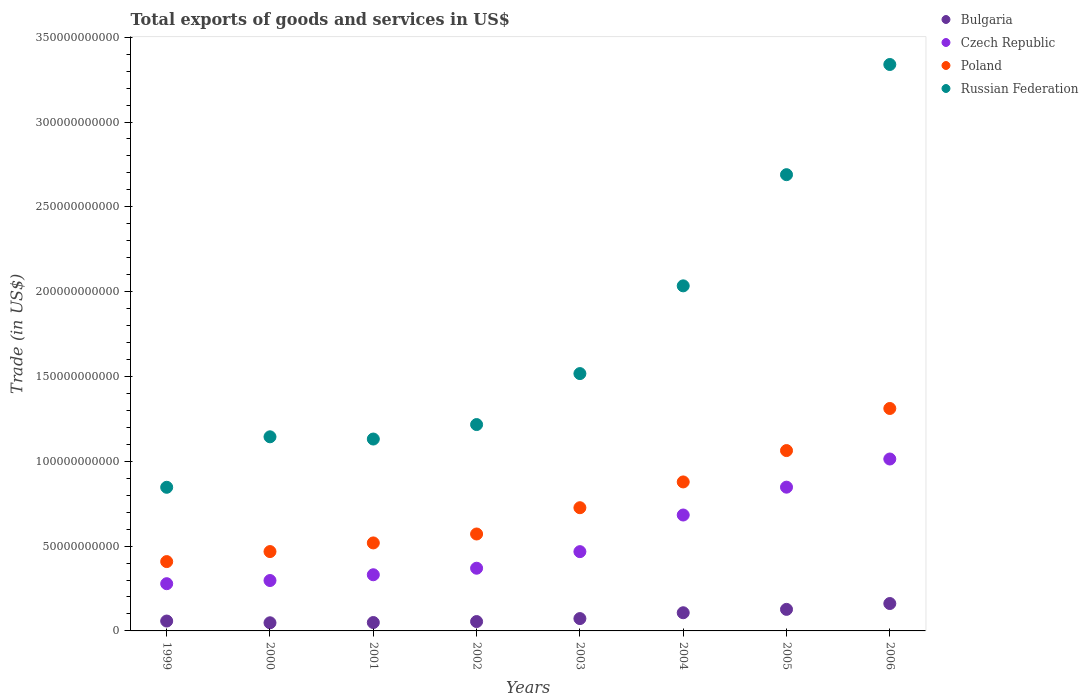What is the total exports of goods and services in Poland in 2003?
Offer a very short reply. 7.26e+1. Across all years, what is the maximum total exports of goods and services in Czech Republic?
Your response must be concise. 1.01e+11. Across all years, what is the minimum total exports of goods and services in Czech Republic?
Your response must be concise. 2.78e+1. In which year was the total exports of goods and services in Czech Republic minimum?
Ensure brevity in your answer.  1999. What is the total total exports of goods and services in Poland in the graph?
Your answer should be compact. 5.95e+11. What is the difference between the total exports of goods and services in Russian Federation in 2001 and that in 2006?
Provide a succinct answer. -2.21e+11. What is the difference between the total exports of goods and services in Czech Republic in 2004 and the total exports of goods and services in Poland in 2002?
Keep it short and to the point. 1.12e+1. What is the average total exports of goods and services in Bulgaria per year?
Offer a very short reply. 8.49e+09. In the year 2001, what is the difference between the total exports of goods and services in Czech Republic and total exports of goods and services in Bulgaria?
Keep it short and to the point. 2.82e+1. What is the ratio of the total exports of goods and services in Russian Federation in 2002 to that in 2003?
Ensure brevity in your answer.  0.8. Is the total exports of goods and services in Bulgaria in 2004 less than that in 2005?
Your answer should be compact. Yes. What is the difference between the highest and the second highest total exports of goods and services in Russian Federation?
Offer a very short reply. 6.50e+1. What is the difference between the highest and the lowest total exports of goods and services in Poland?
Provide a short and direct response. 9.03e+1. In how many years, is the total exports of goods and services in Poland greater than the average total exports of goods and services in Poland taken over all years?
Your answer should be very brief. 3. Is it the case that in every year, the sum of the total exports of goods and services in Poland and total exports of goods and services in Czech Republic  is greater than the sum of total exports of goods and services in Russian Federation and total exports of goods and services in Bulgaria?
Give a very brief answer. Yes. Is it the case that in every year, the sum of the total exports of goods and services in Bulgaria and total exports of goods and services in Poland  is greater than the total exports of goods and services in Czech Republic?
Your answer should be compact. Yes. How many years are there in the graph?
Make the answer very short. 8. What is the difference between two consecutive major ticks on the Y-axis?
Offer a very short reply. 5.00e+1. Does the graph contain grids?
Offer a terse response. No. How many legend labels are there?
Offer a very short reply. 4. What is the title of the graph?
Provide a succinct answer. Total exports of goods and services in US$. Does "Tuvalu" appear as one of the legend labels in the graph?
Offer a terse response. No. What is the label or title of the Y-axis?
Provide a short and direct response. Trade (in US$). What is the Trade (in US$) of Bulgaria in 1999?
Give a very brief answer. 5.83e+09. What is the Trade (in US$) in Czech Republic in 1999?
Provide a succinct answer. 2.78e+1. What is the Trade (in US$) of Poland in 1999?
Offer a very short reply. 4.09e+1. What is the Trade (in US$) in Russian Federation in 1999?
Offer a very short reply. 8.47e+1. What is the Trade (in US$) of Bulgaria in 2000?
Provide a succinct answer. 4.80e+09. What is the Trade (in US$) of Czech Republic in 2000?
Your answer should be compact. 2.97e+1. What is the Trade (in US$) of Poland in 2000?
Offer a very short reply. 4.68e+1. What is the Trade (in US$) in Russian Federation in 2000?
Keep it short and to the point. 1.14e+11. What is the Trade (in US$) in Bulgaria in 2001?
Your answer should be compact. 4.95e+09. What is the Trade (in US$) of Czech Republic in 2001?
Provide a succinct answer. 3.31e+1. What is the Trade (in US$) in Poland in 2001?
Provide a short and direct response. 5.19e+1. What is the Trade (in US$) of Russian Federation in 2001?
Offer a very short reply. 1.13e+11. What is the Trade (in US$) in Bulgaria in 2002?
Your answer should be compact. 5.52e+09. What is the Trade (in US$) in Czech Republic in 2002?
Give a very brief answer. 3.70e+1. What is the Trade (in US$) of Poland in 2002?
Give a very brief answer. 5.71e+1. What is the Trade (in US$) in Russian Federation in 2002?
Keep it short and to the point. 1.22e+11. What is the Trade (in US$) of Bulgaria in 2003?
Ensure brevity in your answer.  7.28e+09. What is the Trade (in US$) in Czech Republic in 2003?
Your answer should be very brief. 4.67e+1. What is the Trade (in US$) of Poland in 2003?
Make the answer very short. 7.26e+1. What is the Trade (in US$) of Russian Federation in 2003?
Give a very brief answer. 1.52e+11. What is the Trade (in US$) in Bulgaria in 2004?
Make the answer very short. 1.07e+1. What is the Trade (in US$) in Czech Republic in 2004?
Your answer should be very brief. 6.83e+1. What is the Trade (in US$) of Poland in 2004?
Keep it short and to the point. 8.78e+1. What is the Trade (in US$) in Russian Federation in 2004?
Your response must be concise. 2.03e+11. What is the Trade (in US$) in Bulgaria in 2005?
Provide a succinct answer. 1.27e+1. What is the Trade (in US$) of Czech Republic in 2005?
Your response must be concise. 8.47e+1. What is the Trade (in US$) of Poland in 2005?
Give a very brief answer. 1.06e+11. What is the Trade (in US$) in Russian Federation in 2005?
Make the answer very short. 2.69e+11. What is the Trade (in US$) of Bulgaria in 2006?
Provide a short and direct response. 1.62e+1. What is the Trade (in US$) in Czech Republic in 2006?
Ensure brevity in your answer.  1.01e+11. What is the Trade (in US$) in Poland in 2006?
Make the answer very short. 1.31e+11. What is the Trade (in US$) of Russian Federation in 2006?
Give a very brief answer. 3.34e+11. Across all years, what is the maximum Trade (in US$) of Bulgaria?
Make the answer very short. 1.62e+1. Across all years, what is the maximum Trade (in US$) of Czech Republic?
Ensure brevity in your answer.  1.01e+11. Across all years, what is the maximum Trade (in US$) in Poland?
Make the answer very short. 1.31e+11. Across all years, what is the maximum Trade (in US$) of Russian Federation?
Your response must be concise. 3.34e+11. Across all years, what is the minimum Trade (in US$) in Bulgaria?
Your answer should be very brief. 4.80e+09. Across all years, what is the minimum Trade (in US$) of Czech Republic?
Offer a terse response. 2.78e+1. Across all years, what is the minimum Trade (in US$) in Poland?
Offer a terse response. 4.09e+1. Across all years, what is the minimum Trade (in US$) in Russian Federation?
Provide a succinct answer. 8.47e+1. What is the total Trade (in US$) in Bulgaria in the graph?
Offer a terse response. 6.79e+1. What is the total Trade (in US$) in Czech Republic in the graph?
Your answer should be compact. 4.29e+11. What is the total Trade (in US$) of Poland in the graph?
Keep it short and to the point. 5.95e+11. What is the total Trade (in US$) in Russian Federation in the graph?
Provide a short and direct response. 1.39e+12. What is the difference between the Trade (in US$) of Bulgaria in 1999 and that in 2000?
Your answer should be very brief. 1.03e+09. What is the difference between the Trade (in US$) of Czech Republic in 1999 and that in 2000?
Your response must be concise. -1.87e+09. What is the difference between the Trade (in US$) in Poland in 1999 and that in 2000?
Offer a terse response. -5.90e+09. What is the difference between the Trade (in US$) in Russian Federation in 1999 and that in 2000?
Your answer should be very brief. -2.98e+1. What is the difference between the Trade (in US$) in Bulgaria in 1999 and that in 2001?
Your answer should be very brief. 8.78e+08. What is the difference between the Trade (in US$) in Czech Republic in 1999 and that in 2001?
Keep it short and to the point. -5.26e+09. What is the difference between the Trade (in US$) in Poland in 1999 and that in 2001?
Offer a very short reply. -1.10e+1. What is the difference between the Trade (in US$) of Russian Federation in 1999 and that in 2001?
Offer a terse response. -2.84e+1. What is the difference between the Trade (in US$) of Bulgaria in 1999 and that in 2002?
Provide a short and direct response. 3.07e+08. What is the difference between the Trade (in US$) in Czech Republic in 1999 and that in 2002?
Keep it short and to the point. -9.12e+09. What is the difference between the Trade (in US$) of Poland in 1999 and that in 2002?
Ensure brevity in your answer.  -1.63e+1. What is the difference between the Trade (in US$) in Russian Federation in 1999 and that in 2002?
Provide a short and direct response. -3.70e+1. What is the difference between the Trade (in US$) of Bulgaria in 1999 and that in 2003?
Offer a terse response. -1.45e+09. What is the difference between the Trade (in US$) in Czech Republic in 1999 and that in 2003?
Offer a terse response. -1.89e+1. What is the difference between the Trade (in US$) of Poland in 1999 and that in 2003?
Provide a succinct answer. -3.18e+1. What is the difference between the Trade (in US$) in Russian Federation in 1999 and that in 2003?
Provide a succinct answer. -6.70e+1. What is the difference between the Trade (in US$) of Bulgaria in 1999 and that in 2004?
Provide a short and direct response. -4.89e+09. What is the difference between the Trade (in US$) of Czech Republic in 1999 and that in 2004?
Provide a succinct answer. -4.05e+1. What is the difference between the Trade (in US$) of Poland in 1999 and that in 2004?
Make the answer very short. -4.70e+1. What is the difference between the Trade (in US$) of Russian Federation in 1999 and that in 2004?
Your answer should be very brief. -1.19e+11. What is the difference between the Trade (in US$) in Bulgaria in 1999 and that in 2005?
Offer a terse response. -6.88e+09. What is the difference between the Trade (in US$) of Czech Republic in 1999 and that in 2005?
Give a very brief answer. -5.69e+1. What is the difference between the Trade (in US$) of Poland in 1999 and that in 2005?
Your response must be concise. -6.54e+1. What is the difference between the Trade (in US$) of Russian Federation in 1999 and that in 2005?
Offer a very short reply. -1.84e+11. What is the difference between the Trade (in US$) in Bulgaria in 1999 and that in 2006?
Give a very brief answer. -1.03e+1. What is the difference between the Trade (in US$) of Czech Republic in 1999 and that in 2006?
Give a very brief answer. -7.35e+1. What is the difference between the Trade (in US$) of Poland in 1999 and that in 2006?
Provide a short and direct response. -9.03e+1. What is the difference between the Trade (in US$) of Russian Federation in 1999 and that in 2006?
Provide a short and direct response. -2.49e+11. What is the difference between the Trade (in US$) in Bulgaria in 2000 and that in 2001?
Provide a short and direct response. -1.50e+08. What is the difference between the Trade (in US$) of Czech Republic in 2000 and that in 2001?
Keep it short and to the point. -3.40e+09. What is the difference between the Trade (in US$) in Poland in 2000 and that in 2001?
Your answer should be very brief. -5.10e+09. What is the difference between the Trade (in US$) of Russian Federation in 2000 and that in 2001?
Ensure brevity in your answer.  1.31e+09. What is the difference between the Trade (in US$) of Bulgaria in 2000 and that in 2002?
Offer a very short reply. -7.22e+08. What is the difference between the Trade (in US$) in Czech Republic in 2000 and that in 2002?
Make the answer very short. -7.25e+09. What is the difference between the Trade (in US$) of Poland in 2000 and that in 2002?
Offer a terse response. -1.04e+1. What is the difference between the Trade (in US$) of Russian Federation in 2000 and that in 2002?
Your answer should be compact. -7.22e+09. What is the difference between the Trade (in US$) of Bulgaria in 2000 and that in 2003?
Make the answer very short. -2.48e+09. What is the difference between the Trade (in US$) of Czech Republic in 2000 and that in 2003?
Offer a terse response. -1.70e+1. What is the difference between the Trade (in US$) of Poland in 2000 and that in 2003?
Keep it short and to the point. -2.59e+1. What is the difference between the Trade (in US$) in Russian Federation in 2000 and that in 2003?
Ensure brevity in your answer.  -3.73e+1. What is the difference between the Trade (in US$) in Bulgaria in 2000 and that in 2004?
Provide a short and direct response. -5.92e+09. What is the difference between the Trade (in US$) in Czech Republic in 2000 and that in 2004?
Keep it short and to the point. -3.86e+1. What is the difference between the Trade (in US$) in Poland in 2000 and that in 2004?
Make the answer very short. -4.11e+1. What is the difference between the Trade (in US$) in Russian Federation in 2000 and that in 2004?
Provide a succinct answer. -8.90e+1. What is the difference between the Trade (in US$) in Bulgaria in 2000 and that in 2005?
Your answer should be compact. -7.91e+09. What is the difference between the Trade (in US$) of Czech Republic in 2000 and that in 2005?
Keep it short and to the point. -5.50e+1. What is the difference between the Trade (in US$) in Poland in 2000 and that in 2005?
Offer a very short reply. -5.95e+1. What is the difference between the Trade (in US$) of Russian Federation in 2000 and that in 2005?
Offer a terse response. -1.55e+11. What is the difference between the Trade (in US$) of Bulgaria in 2000 and that in 2006?
Offer a very short reply. -1.14e+1. What is the difference between the Trade (in US$) of Czech Republic in 2000 and that in 2006?
Make the answer very short. -7.16e+1. What is the difference between the Trade (in US$) of Poland in 2000 and that in 2006?
Keep it short and to the point. -8.44e+1. What is the difference between the Trade (in US$) of Russian Federation in 2000 and that in 2006?
Your answer should be compact. -2.19e+11. What is the difference between the Trade (in US$) of Bulgaria in 2001 and that in 2002?
Ensure brevity in your answer.  -5.72e+08. What is the difference between the Trade (in US$) of Czech Republic in 2001 and that in 2002?
Give a very brief answer. -3.86e+09. What is the difference between the Trade (in US$) of Poland in 2001 and that in 2002?
Keep it short and to the point. -5.26e+09. What is the difference between the Trade (in US$) in Russian Federation in 2001 and that in 2002?
Your response must be concise. -8.53e+09. What is the difference between the Trade (in US$) of Bulgaria in 2001 and that in 2003?
Offer a terse response. -2.33e+09. What is the difference between the Trade (in US$) in Czech Republic in 2001 and that in 2003?
Your answer should be compact. -1.36e+1. What is the difference between the Trade (in US$) of Poland in 2001 and that in 2003?
Offer a very short reply. -2.08e+1. What is the difference between the Trade (in US$) in Russian Federation in 2001 and that in 2003?
Provide a succinct answer. -3.86e+1. What is the difference between the Trade (in US$) of Bulgaria in 2001 and that in 2004?
Give a very brief answer. -5.77e+09. What is the difference between the Trade (in US$) in Czech Republic in 2001 and that in 2004?
Your response must be concise. -3.52e+1. What is the difference between the Trade (in US$) of Poland in 2001 and that in 2004?
Make the answer very short. -3.60e+1. What is the difference between the Trade (in US$) in Russian Federation in 2001 and that in 2004?
Your answer should be very brief. -9.03e+1. What is the difference between the Trade (in US$) in Bulgaria in 2001 and that in 2005?
Give a very brief answer. -7.76e+09. What is the difference between the Trade (in US$) of Czech Republic in 2001 and that in 2005?
Offer a very short reply. -5.16e+1. What is the difference between the Trade (in US$) of Poland in 2001 and that in 2005?
Provide a succinct answer. -5.44e+1. What is the difference between the Trade (in US$) in Russian Federation in 2001 and that in 2005?
Provide a short and direct response. -1.56e+11. What is the difference between the Trade (in US$) in Bulgaria in 2001 and that in 2006?
Your answer should be compact. -1.12e+1. What is the difference between the Trade (in US$) in Czech Republic in 2001 and that in 2006?
Give a very brief answer. -6.82e+1. What is the difference between the Trade (in US$) of Poland in 2001 and that in 2006?
Your answer should be compact. -7.93e+1. What is the difference between the Trade (in US$) in Russian Federation in 2001 and that in 2006?
Make the answer very short. -2.21e+11. What is the difference between the Trade (in US$) of Bulgaria in 2002 and that in 2003?
Make the answer very short. -1.76e+09. What is the difference between the Trade (in US$) of Czech Republic in 2002 and that in 2003?
Your response must be concise. -9.77e+09. What is the difference between the Trade (in US$) of Poland in 2002 and that in 2003?
Offer a very short reply. -1.55e+1. What is the difference between the Trade (in US$) in Russian Federation in 2002 and that in 2003?
Provide a succinct answer. -3.00e+1. What is the difference between the Trade (in US$) of Bulgaria in 2002 and that in 2004?
Offer a terse response. -5.19e+09. What is the difference between the Trade (in US$) of Czech Republic in 2002 and that in 2004?
Your response must be concise. -3.14e+1. What is the difference between the Trade (in US$) of Poland in 2002 and that in 2004?
Your answer should be very brief. -3.07e+1. What is the difference between the Trade (in US$) in Russian Federation in 2002 and that in 2004?
Keep it short and to the point. -8.18e+1. What is the difference between the Trade (in US$) in Bulgaria in 2002 and that in 2005?
Keep it short and to the point. -7.18e+09. What is the difference between the Trade (in US$) of Czech Republic in 2002 and that in 2005?
Offer a very short reply. -4.78e+1. What is the difference between the Trade (in US$) of Poland in 2002 and that in 2005?
Give a very brief answer. -4.92e+1. What is the difference between the Trade (in US$) in Russian Federation in 2002 and that in 2005?
Make the answer very short. -1.47e+11. What is the difference between the Trade (in US$) of Bulgaria in 2002 and that in 2006?
Give a very brief answer. -1.06e+1. What is the difference between the Trade (in US$) of Czech Republic in 2002 and that in 2006?
Give a very brief answer. -6.44e+1. What is the difference between the Trade (in US$) of Poland in 2002 and that in 2006?
Keep it short and to the point. -7.40e+1. What is the difference between the Trade (in US$) of Russian Federation in 2002 and that in 2006?
Give a very brief answer. -2.12e+11. What is the difference between the Trade (in US$) in Bulgaria in 2003 and that in 2004?
Offer a terse response. -3.44e+09. What is the difference between the Trade (in US$) of Czech Republic in 2003 and that in 2004?
Keep it short and to the point. -2.16e+1. What is the difference between the Trade (in US$) in Poland in 2003 and that in 2004?
Keep it short and to the point. -1.52e+1. What is the difference between the Trade (in US$) of Russian Federation in 2003 and that in 2004?
Offer a terse response. -5.17e+1. What is the difference between the Trade (in US$) in Bulgaria in 2003 and that in 2005?
Ensure brevity in your answer.  -5.43e+09. What is the difference between the Trade (in US$) in Czech Republic in 2003 and that in 2005?
Offer a terse response. -3.80e+1. What is the difference between the Trade (in US$) in Poland in 2003 and that in 2005?
Your answer should be compact. -3.37e+1. What is the difference between the Trade (in US$) of Russian Federation in 2003 and that in 2005?
Your answer should be very brief. -1.17e+11. What is the difference between the Trade (in US$) in Bulgaria in 2003 and that in 2006?
Your answer should be very brief. -8.87e+09. What is the difference between the Trade (in US$) of Czech Republic in 2003 and that in 2006?
Your answer should be very brief. -5.46e+1. What is the difference between the Trade (in US$) in Poland in 2003 and that in 2006?
Provide a short and direct response. -5.85e+1. What is the difference between the Trade (in US$) of Russian Federation in 2003 and that in 2006?
Your answer should be compact. -1.82e+11. What is the difference between the Trade (in US$) in Bulgaria in 2004 and that in 2005?
Make the answer very short. -1.99e+09. What is the difference between the Trade (in US$) of Czech Republic in 2004 and that in 2005?
Your response must be concise. -1.64e+1. What is the difference between the Trade (in US$) of Poland in 2004 and that in 2005?
Offer a very short reply. -1.85e+1. What is the difference between the Trade (in US$) of Russian Federation in 2004 and that in 2005?
Provide a short and direct response. -6.55e+1. What is the difference between the Trade (in US$) in Bulgaria in 2004 and that in 2006?
Offer a very short reply. -5.44e+09. What is the difference between the Trade (in US$) in Czech Republic in 2004 and that in 2006?
Offer a terse response. -3.30e+1. What is the difference between the Trade (in US$) of Poland in 2004 and that in 2006?
Your response must be concise. -4.33e+1. What is the difference between the Trade (in US$) in Russian Federation in 2004 and that in 2006?
Your response must be concise. -1.30e+11. What is the difference between the Trade (in US$) of Bulgaria in 2005 and that in 2006?
Offer a very short reply. -3.45e+09. What is the difference between the Trade (in US$) in Czech Republic in 2005 and that in 2006?
Give a very brief answer. -1.66e+1. What is the difference between the Trade (in US$) of Poland in 2005 and that in 2006?
Give a very brief answer. -2.48e+1. What is the difference between the Trade (in US$) of Russian Federation in 2005 and that in 2006?
Your response must be concise. -6.50e+1. What is the difference between the Trade (in US$) of Bulgaria in 1999 and the Trade (in US$) of Czech Republic in 2000?
Your answer should be very brief. -2.39e+1. What is the difference between the Trade (in US$) of Bulgaria in 1999 and the Trade (in US$) of Poland in 2000?
Your response must be concise. -4.09e+1. What is the difference between the Trade (in US$) in Bulgaria in 1999 and the Trade (in US$) in Russian Federation in 2000?
Ensure brevity in your answer.  -1.09e+11. What is the difference between the Trade (in US$) of Czech Republic in 1999 and the Trade (in US$) of Poland in 2000?
Provide a succinct answer. -1.89e+1. What is the difference between the Trade (in US$) in Czech Republic in 1999 and the Trade (in US$) in Russian Federation in 2000?
Provide a short and direct response. -8.66e+1. What is the difference between the Trade (in US$) in Poland in 1999 and the Trade (in US$) in Russian Federation in 2000?
Keep it short and to the point. -7.36e+1. What is the difference between the Trade (in US$) of Bulgaria in 1999 and the Trade (in US$) of Czech Republic in 2001?
Provide a short and direct response. -2.73e+1. What is the difference between the Trade (in US$) in Bulgaria in 1999 and the Trade (in US$) in Poland in 2001?
Provide a succinct answer. -4.60e+1. What is the difference between the Trade (in US$) in Bulgaria in 1999 and the Trade (in US$) in Russian Federation in 2001?
Make the answer very short. -1.07e+11. What is the difference between the Trade (in US$) in Czech Republic in 1999 and the Trade (in US$) in Poland in 2001?
Give a very brief answer. -2.40e+1. What is the difference between the Trade (in US$) in Czech Republic in 1999 and the Trade (in US$) in Russian Federation in 2001?
Your answer should be compact. -8.53e+1. What is the difference between the Trade (in US$) in Poland in 1999 and the Trade (in US$) in Russian Federation in 2001?
Give a very brief answer. -7.22e+1. What is the difference between the Trade (in US$) of Bulgaria in 1999 and the Trade (in US$) of Czech Republic in 2002?
Provide a succinct answer. -3.11e+1. What is the difference between the Trade (in US$) of Bulgaria in 1999 and the Trade (in US$) of Poland in 2002?
Provide a succinct answer. -5.13e+1. What is the difference between the Trade (in US$) in Bulgaria in 1999 and the Trade (in US$) in Russian Federation in 2002?
Provide a short and direct response. -1.16e+11. What is the difference between the Trade (in US$) in Czech Republic in 1999 and the Trade (in US$) in Poland in 2002?
Make the answer very short. -2.93e+1. What is the difference between the Trade (in US$) in Czech Republic in 1999 and the Trade (in US$) in Russian Federation in 2002?
Provide a short and direct response. -9.38e+1. What is the difference between the Trade (in US$) in Poland in 1999 and the Trade (in US$) in Russian Federation in 2002?
Your answer should be very brief. -8.08e+1. What is the difference between the Trade (in US$) in Bulgaria in 1999 and the Trade (in US$) in Czech Republic in 2003?
Your response must be concise. -4.09e+1. What is the difference between the Trade (in US$) in Bulgaria in 1999 and the Trade (in US$) in Poland in 2003?
Ensure brevity in your answer.  -6.68e+1. What is the difference between the Trade (in US$) of Bulgaria in 1999 and the Trade (in US$) of Russian Federation in 2003?
Give a very brief answer. -1.46e+11. What is the difference between the Trade (in US$) in Czech Republic in 1999 and the Trade (in US$) in Poland in 2003?
Ensure brevity in your answer.  -4.48e+1. What is the difference between the Trade (in US$) of Czech Republic in 1999 and the Trade (in US$) of Russian Federation in 2003?
Make the answer very short. -1.24e+11. What is the difference between the Trade (in US$) in Poland in 1999 and the Trade (in US$) in Russian Federation in 2003?
Your answer should be compact. -1.11e+11. What is the difference between the Trade (in US$) of Bulgaria in 1999 and the Trade (in US$) of Czech Republic in 2004?
Keep it short and to the point. -6.25e+1. What is the difference between the Trade (in US$) of Bulgaria in 1999 and the Trade (in US$) of Poland in 2004?
Your response must be concise. -8.20e+1. What is the difference between the Trade (in US$) of Bulgaria in 1999 and the Trade (in US$) of Russian Federation in 2004?
Offer a very short reply. -1.98e+11. What is the difference between the Trade (in US$) of Czech Republic in 1999 and the Trade (in US$) of Poland in 2004?
Your answer should be very brief. -6.00e+1. What is the difference between the Trade (in US$) of Czech Republic in 1999 and the Trade (in US$) of Russian Federation in 2004?
Keep it short and to the point. -1.76e+11. What is the difference between the Trade (in US$) of Poland in 1999 and the Trade (in US$) of Russian Federation in 2004?
Give a very brief answer. -1.63e+11. What is the difference between the Trade (in US$) in Bulgaria in 1999 and the Trade (in US$) in Czech Republic in 2005?
Offer a very short reply. -7.89e+1. What is the difference between the Trade (in US$) in Bulgaria in 1999 and the Trade (in US$) in Poland in 2005?
Your answer should be compact. -1.00e+11. What is the difference between the Trade (in US$) of Bulgaria in 1999 and the Trade (in US$) of Russian Federation in 2005?
Provide a succinct answer. -2.63e+11. What is the difference between the Trade (in US$) in Czech Republic in 1999 and the Trade (in US$) in Poland in 2005?
Provide a short and direct response. -7.85e+1. What is the difference between the Trade (in US$) in Czech Republic in 1999 and the Trade (in US$) in Russian Federation in 2005?
Ensure brevity in your answer.  -2.41e+11. What is the difference between the Trade (in US$) in Poland in 1999 and the Trade (in US$) in Russian Federation in 2005?
Your response must be concise. -2.28e+11. What is the difference between the Trade (in US$) of Bulgaria in 1999 and the Trade (in US$) of Czech Republic in 2006?
Provide a succinct answer. -9.55e+1. What is the difference between the Trade (in US$) in Bulgaria in 1999 and the Trade (in US$) in Poland in 2006?
Provide a short and direct response. -1.25e+11. What is the difference between the Trade (in US$) of Bulgaria in 1999 and the Trade (in US$) of Russian Federation in 2006?
Provide a short and direct response. -3.28e+11. What is the difference between the Trade (in US$) in Czech Republic in 1999 and the Trade (in US$) in Poland in 2006?
Make the answer very short. -1.03e+11. What is the difference between the Trade (in US$) in Czech Republic in 1999 and the Trade (in US$) in Russian Federation in 2006?
Make the answer very short. -3.06e+11. What is the difference between the Trade (in US$) in Poland in 1999 and the Trade (in US$) in Russian Federation in 2006?
Provide a succinct answer. -2.93e+11. What is the difference between the Trade (in US$) in Bulgaria in 2000 and the Trade (in US$) in Czech Republic in 2001?
Offer a terse response. -2.83e+1. What is the difference between the Trade (in US$) of Bulgaria in 2000 and the Trade (in US$) of Poland in 2001?
Make the answer very short. -4.71e+1. What is the difference between the Trade (in US$) of Bulgaria in 2000 and the Trade (in US$) of Russian Federation in 2001?
Give a very brief answer. -1.08e+11. What is the difference between the Trade (in US$) in Czech Republic in 2000 and the Trade (in US$) in Poland in 2001?
Keep it short and to the point. -2.22e+1. What is the difference between the Trade (in US$) of Czech Republic in 2000 and the Trade (in US$) of Russian Federation in 2001?
Your response must be concise. -8.34e+1. What is the difference between the Trade (in US$) in Poland in 2000 and the Trade (in US$) in Russian Federation in 2001?
Offer a terse response. -6.63e+1. What is the difference between the Trade (in US$) of Bulgaria in 2000 and the Trade (in US$) of Czech Republic in 2002?
Your answer should be very brief. -3.22e+1. What is the difference between the Trade (in US$) of Bulgaria in 2000 and the Trade (in US$) of Poland in 2002?
Offer a terse response. -5.23e+1. What is the difference between the Trade (in US$) of Bulgaria in 2000 and the Trade (in US$) of Russian Federation in 2002?
Offer a terse response. -1.17e+11. What is the difference between the Trade (in US$) of Czech Republic in 2000 and the Trade (in US$) of Poland in 2002?
Your response must be concise. -2.74e+1. What is the difference between the Trade (in US$) in Czech Republic in 2000 and the Trade (in US$) in Russian Federation in 2002?
Your response must be concise. -9.19e+1. What is the difference between the Trade (in US$) of Poland in 2000 and the Trade (in US$) of Russian Federation in 2002?
Your answer should be compact. -7.49e+1. What is the difference between the Trade (in US$) of Bulgaria in 2000 and the Trade (in US$) of Czech Republic in 2003?
Your answer should be compact. -4.19e+1. What is the difference between the Trade (in US$) in Bulgaria in 2000 and the Trade (in US$) in Poland in 2003?
Your answer should be compact. -6.78e+1. What is the difference between the Trade (in US$) in Bulgaria in 2000 and the Trade (in US$) in Russian Federation in 2003?
Your answer should be very brief. -1.47e+11. What is the difference between the Trade (in US$) in Czech Republic in 2000 and the Trade (in US$) in Poland in 2003?
Make the answer very short. -4.29e+1. What is the difference between the Trade (in US$) of Czech Republic in 2000 and the Trade (in US$) of Russian Federation in 2003?
Your answer should be compact. -1.22e+11. What is the difference between the Trade (in US$) in Poland in 2000 and the Trade (in US$) in Russian Federation in 2003?
Make the answer very short. -1.05e+11. What is the difference between the Trade (in US$) in Bulgaria in 2000 and the Trade (in US$) in Czech Republic in 2004?
Provide a short and direct response. -6.35e+1. What is the difference between the Trade (in US$) of Bulgaria in 2000 and the Trade (in US$) of Poland in 2004?
Your answer should be compact. -8.30e+1. What is the difference between the Trade (in US$) in Bulgaria in 2000 and the Trade (in US$) in Russian Federation in 2004?
Offer a very short reply. -1.99e+11. What is the difference between the Trade (in US$) in Czech Republic in 2000 and the Trade (in US$) in Poland in 2004?
Keep it short and to the point. -5.81e+1. What is the difference between the Trade (in US$) of Czech Republic in 2000 and the Trade (in US$) of Russian Federation in 2004?
Keep it short and to the point. -1.74e+11. What is the difference between the Trade (in US$) of Poland in 2000 and the Trade (in US$) of Russian Federation in 2004?
Offer a very short reply. -1.57e+11. What is the difference between the Trade (in US$) of Bulgaria in 2000 and the Trade (in US$) of Czech Republic in 2005?
Provide a succinct answer. -7.99e+1. What is the difference between the Trade (in US$) of Bulgaria in 2000 and the Trade (in US$) of Poland in 2005?
Ensure brevity in your answer.  -1.02e+11. What is the difference between the Trade (in US$) of Bulgaria in 2000 and the Trade (in US$) of Russian Federation in 2005?
Ensure brevity in your answer.  -2.64e+11. What is the difference between the Trade (in US$) of Czech Republic in 2000 and the Trade (in US$) of Poland in 2005?
Your response must be concise. -7.66e+1. What is the difference between the Trade (in US$) of Czech Republic in 2000 and the Trade (in US$) of Russian Federation in 2005?
Offer a terse response. -2.39e+11. What is the difference between the Trade (in US$) of Poland in 2000 and the Trade (in US$) of Russian Federation in 2005?
Your response must be concise. -2.22e+11. What is the difference between the Trade (in US$) in Bulgaria in 2000 and the Trade (in US$) in Czech Republic in 2006?
Give a very brief answer. -9.65e+1. What is the difference between the Trade (in US$) of Bulgaria in 2000 and the Trade (in US$) of Poland in 2006?
Offer a terse response. -1.26e+11. What is the difference between the Trade (in US$) in Bulgaria in 2000 and the Trade (in US$) in Russian Federation in 2006?
Your response must be concise. -3.29e+11. What is the difference between the Trade (in US$) in Czech Republic in 2000 and the Trade (in US$) in Poland in 2006?
Your answer should be compact. -1.01e+11. What is the difference between the Trade (in US$) in Czech Republic in 2000 and the Trade (in US$) in Russian Federation in 2006?
Your response must be concise. -3.04e+11. What is the difference between the Trade (in US$) in Poland in 2000 and the Trade (in US$) in Russian Federation in 2006?
Offer a terse response. -2.87e+11. What is the difference between the Trade (in US$) in Bulgaria in 2001 and the Trade (in US$) in Czech Republic in 2002?
Your answer should be compact. -3.20e+1. What is the difference between the Trade (in US$) in Bulgaria in 2001 and the Trade (in US$) in Poland in 2002?
Your answer should be very brief. -5.22e+1. What is the difference between the Trade (in US$) in Bulgaria in 2001 and the Trade (in US$) in Russian Federation in 2002?
Your answer should be very brief. -1.17e+11. What is the difference between the Trade (in US$) in Czech Republic in 2001 and the Trade (in US$) in Poland in 2002?
Your response must be concise. -2.40e+1. What is the difference between the Trade (in US$) in Czech Republic in 2001 and the Trade (in US$) in Russian Federation in 2002?
Ensure brevity in your answer.  -8.85e+1. What is the difference between the Trade (in US$) of Poland in 2001 and the Trade (in US$) of Russian Federation in 2002?
Make the answer very short. -6.98e+1. What is the difference between the Trade (in US$) in Bulgaria in 2001 and the Trade (in US$) in Czech Republic in 2003?
Offer a terse response. -4.18e+1. What is the difference between the Trade (in US$) in Bulgaria in 2001 and the Trade (in US$) in Poland in 2003?
Your answer should be very brief. -6.77e+1. What is the difference between the Trade (in US$) of Bulgaria in 2001 and the Trade (in US$) of Russian Federation in 2003?
Your response must be concise. -1.47e+11. What is the difference between the Trade (in US$) of Czech Republic in 2001 and the Trade (in US$) of Poland in 2003?
Your response must be concise. -3.95e+1. What is the difference between the Trade (in US$) in Czech Republic in 2001 and the Trade (in US$) in Russian Federation in 2003?
Make the answer very short. -1.19e+11. What is the difference between the Trade (in US$) of Poland in 2001 and the Trade (in US$) of Russian Federation in 2003?
Keep it short and to the point. -9.98e+1. What is the difference between the Trade (in US$) of Bulgaria in 2001 and the Trade (in US$) of Czech Republic in 2004?
Your response must be concise. -6.34e+1. What is the difference between the Trade (in US$) in Bulgaria in 2001 and the Trade (in US$) in Poland in 2004?
Your response must be concise. -8.29e+1. What is the difference between the Trade (in US$) of Bulgaria in 2001 and the Trade (in US$) of Russian Federation in 2004?
Offer a terse response. -1.98e+11. What is the difference between the Trade (in US$) in Czech Republic in 2001 and the Trade (in US$) in Poland in 2004?
Offer a terse response. -5.47e+1. What is the difference between the Trade (in US$) in Czech Republic in 2001 and the Trade (in US$) in Russian Federation in 2004?
Your response must be concise. -1.70e+11. What is the difference between the Trade (in US$) of Poland in 2001 and the Trade (in US$) of Russian Federation in 2004?
Your answer should be compact. -1.52e+11. What is the difference between the Trade (in US$) of Bulgaria in 2001 and the Trade (in US$) of Czech Republic in 2005?
Your response must be concise. -7.98e+1. What is the difference between the Trade (in US$) in Bulgaria in 2001 and the Trade (in US$) in Poland in 2005?
Your response must be concise. -1.01e+11. What is the difference between the Trade (in US$) in Bulgaria in 2001 and the Trade (in US$) in Russian Federation in 2005?
Offer a very short reply. -2.64e+11. What is the difference between the Trade (in US$) of Czech Republic in 2001 and the Trade (in US$) of Poland in 2005?
Offer a very short reply. -7.32e+1. What is the difference between the Trade (in US$) in Czech Republic in 2001 and the Trade (in US$) in Russian Federation in 2005?
Your answer should be very brief. -2.36e+11. What is the difference between the Trade (in US$) in Poland in 2001 and the Trade (in US$) in Russian Federation in 2005?
Make the answer very short. -2.17e+11. What is the difference between the Trade (in US$) in Bulgaria in 2001 and the Trade (in US$) in Czech Republic in 2006?
Provide a succinct answer. -9.64e+1. What is the difference between the Trade (in US$) in Bulgaria in 2001 and the Trade (in US$) in Poland in 2006?
Your response must be concise. -1.26e+11. What is the difference between the Trade (in US$) in Bulgaria in 2001 and the Trade (in US$) in Russian Federation in 2006?
Ensure brevity in your answer.  -3.29e+11. What is the difference between the Trade (in US$) of Czech Republic in 2001 and the Trade (in US$) of Poland in 2006?
Your answer should be compact. -9.80e+1. What is the difference between the Trade (in US$) in Czech Republic in 2001 and the Trade (in US$) in Russian Federation in 2006?
Your response must be concise. -3.01e+11. What is the difference between the Trade (in US$) of Poland in 2001 and the Trade (in US$) of Russian Federation in 2006?
Ensure brevity in your answer.  -2.82e+11. What is the difference between the Trade (in US$) of Bulgaria in 2002 and the Trade (in US$) of Czech Republic in 2003?
Provide a succinct answer. -4.12e+1. What is the difference between the Trade (in US$) of Bulgaria in 2002 and the Trade (in US$) of Poland in 2003?
Your answer should be very brief. -6.71e+1. What is the difference between the Trade (in US$) of Bulgaria in 2002 and the Trade (in US$) of Russian Federation in 2003?
Provide a succinct answer. -1.46e+11. What is the difference between the Trade (in US$) of Czech Republic in 2002 and the Trade (in US$) of Poland in 2003?
Your answer should be compact. -3.57e+1. What is the difference between the Trade (in US$) of Czech Republic in 2002 and the Trade (in US$) of Russian Federation in 2003?
Make the answer very short. -1.15e+11. What is the difference between the Trade (in US$) of Poland in 2002 and the Trade (in US$) of Russian Federation in 2003?
Give a very brief answer. -9.46e+1. What is the difference between the Trade (in US$) of Bulgaria in 2002 and the Trade (in US$) of Czech Republic in 2004?
Your response must be concise. -6.28e+1. What is the difference between the Trade (in US$) of Bulgaria in 2002 and the Trade (in US$) of Poland in 2004?
Your answer should be compact. -8.23e+1. What is the difference between the Trade (in US$) in Bulgaria in 2002 and the Trade (in US$) in Russian Federation in 2004?
Your answer should be compact. -1.98e+11. What is the difference between the Trade (in US$) of Czech Republic in 2002 and the Trade (in US$) of Poland in 2004?
Provide a succinct answer. -5.09e+1. What is the difference between the Trade (in US$) in Czech Republic in 2002 and the Trade (in US$) in Russian Federation in 2004?
Ensure brevity in your answer.  -1.66e+11. What is the difference between the Trade (in US$) in Poland in 2002 and the Trade (in US$) in Russian Federation in 2004?
Offer a terse response. -1.46e+11. What is the difference between the Trade (in US$) of Bulgaria in 2002 and the Trade (in US$) of Czech Republic in 2005?
Offer a terse response. -7.92e+1. What is the difference between the Trade (in US$) of Bulgaria in 2002 and the Trade (in US$) of Poland in 2005?
Your answer should be very brief. -1.01e+11. What is the difference between the Trade (in US$) of Bulgaria in 2002 and the Trade (in US$) of Russian Federation in 2005?
Ensure brevity in your answer.  -2.63e+11. What is the difference between the Trade (in US$) of Czech Republic in 2002 and the Trade (in US$) of Poland in 2005?
Offer a terse response. -6.94e+1. What is the difference between the Trade (in US$) of Czech Republic in 2002 and the Trade (in US$) of Russian Federation in 2005?
Your answer should be compact. -2.32e+11. What is the difference between the Trade (in US$) of Poland in 2002 and the Trade (in US$) of Russian Federation in 2005?
Ensure brevity in your answer.  -2.12e+11. What is the difference between the Trade (in US$) of Bulgaria in 2002 and the Trade (in US$) of Czech Republic in 2006?
Provide a short and direct response. -9.58e+1. What is the difference between the Trade (in US$) in Bulgaria in 2002 and the Trade (in US$) in Poland in 2006?
Your response must be concise. -1.26e+11. What is the difference between the Trade (in US$) of Bulgaria in 2002 and the Trade (in US$) of Russian Federation in 2006?
Provide a succinct answer. -3.28e+11. What is the difference between the Trade (in US$) of Czech Republic in 2002 and the Trade (in US$) of Poland in 2006?
Your answer should be very brief. -9.42e+1. What is the difference between the Trade (in US$) in Czech Republic in 2002 and the Trade (in US$) in Russian Federation in 2006?
Make the answer very short. -2.97e+11. What is the difference between the Trade (in US$) of Poland in 2002 and the Trade (in US$) of Russian Federation in 2006?
Make the answer very short. -2.77e+11. What is the difference between the Trade (in US$) in Bulgaria in 2003 and the Trade (in US$) in Czech Republic in 2004?
Your answer should be compact. -6.11e+1. What is the difference between the Trade (in US$) of Bulgaria in 2003 and the Trade (in US$) of Poland in 2004?
Your response must be concise. -8.05e+1. What is the difference between the Trade (in US$) in Bulgaria in 2003 and the Trade (in US$) in Russian Federation in 2004?
Your answer should be compact. -1.96e+11. What is the difference between the Trade (in US$) in Czech Republic in 2003 and the Trade (in US$) in Poland in 2004?
Provide a succinct answer. -4.11e+1. What is the difference between the Trade (in US$) of Czech Republic in 2003 and the Trade (in US$) of Russian Federation in 2004?
Your answer should be very brief. -1.57e+11. What is the difference between the Trade (in US$) in Poland in 2003 and the Trade (in US$) in Russian Federation in 2004?
Keep it short and to the point. -1.31e+11. What is the difference between the Trade (in US$) of Bulgaria in 2003 and the Trade (in US$) of Czech Republic in 2005?
Offer a very short reply. -7.75e+1. What is the difference between the Trade (in US$) in Bulgaria in 2003 and the Trade (in US$) in Poland in 2005?
Make the answer very short. -9.90e+1. What is the difference between the Trade (in US$) of Bulgaria in 2003 and the Trade (in US$) of Russian Federation in 2005?
Provide a short and direct response. -2.62e+11. What is the difference between the Trade (in US$) in Czech Republic in 2003 and the Trade (in US$) in Poland in 2005?
Provide a succinct answer. -5.96e+1. What is the difference between the Trade (in US$) of Czech Republic in 2003 and the Trade (in US$) of Russian Federation in 2005?
Ensure brevity in your answer.  -2.22e+11. What is the difference between the Trade (in US$) of Poland in 2003 and the Trade (in US$) of Russian Federation in 2005?
Make the answer very short. -1.96e+11. What is the difference between the Trade (in US$) of Bulgaria in 2003 and the Trade (in US$) of Czech Republic in 2006?
Your answer should be compact. -9.41e+1. What is the difference between the Trade (in US$) in Bulgaria in 2003 and the Trade (in US$) in Poland in 2006?
Provide a succinct answer. -1.24e+11. What is the difference between the Trade (in US$) of Bulgaria in 2003 and the Trade (in US$) of Russian Federation in 2006?
Your answer should be very brief. -3.27e+11. What is the difference between the Trade (in US$) of Czech Republic in 2003 and the Trade (in US$) of Poland in 2006?
Provide a short and direct response. -8.44e+1. What is the difference between the Trade (in US$) in Czech Republic in 2003 and the Trade (in US$) in Russian Federation in 2006?
Ensure brevity in your answer.  -2.87e+11. What is the difference between the Trade (in US$) in Poland in 2003 and the Trade (in US$) in Russian Federation in 2006?
Your answer should be very brief. -2.61e+11. What is the difference between the Trade (in US$) in Bulgaria in 2004 and the Trade (in US$) in Czech Republic in 2005?
Your response must be concise. -7.40e+1. What is the difference between the Trade (in US$) in Bulgaria in 2004 and the Trade (in US$) in Poland in 2005?
Your answer should be compact. -9.56e+1. What is the difference between the Trade (in US$) in Bulgaria in 2004 and the Trade (in US$) in Russian Federation in 2005?
Provide a short and direct response. -2.58e+11. What is the difference between the Trade (in US$) of Czech Republic in 2004 and the Trade (in US$) of Poland in 2005?
Provide a short and direct response. -3.80e+1. What is the difference between the Trade (in US$) in Czech Republic in 2004 and the Trade (in US$) in Russian Federation in 2005?
Provide a short and direct response. -2.01e+11. What is the difference between the Trade (in US$) of Poland in 2004 and the Trade (in US$) of Russian Federation in 2005?
Give a very brief answer. -1.81e+11. What is the difference between the Trade (in US$) in Bulgaria in 2004 and the Trade (in US$) in Czech Republic in 2006?
Ensure brevity in your answer.  -9.06e+1. What is the difference between the Trade (in US$) in Bulgaria in 2004 and the Trade (in US$) in Poland in 2006?
Your answer should be very brief. -1.20e+11. What is the difference between the Trade (in US$) in Bulgaria in 2004 and the Trade (in US$) in Russian Federation in 2006?
Keep it short and to the point. -3.23e+11. What is the difference between the Trade (in US$) in Czech Republic in 2004 and the Trade (in US$) in Poland in 2006?
Keep it short and to the point. -6.28e+1. What is the difference between the Trade (in US$) of Czech Republic in 2004 and the Trade (in US$) of Russian Federation in 2006?
Make the answer very short. -2.66e+11. What is the difference between the Trade (in US$) of Poland in 2004 and the Trade (in US$) of Russian Federation in 2006?
Make the answer very short. -2.46e+11. What is the difference between the Trade (in US$) in Bulgaria in 2005 and the Trade (in US$) in Czech Republic in 2006?
Offer a very short reply. -8.86e+1. What is the difference between the Trade (in US$) of Bulgaria in 2005 and the Trade (in US$) of Poland in 2006?
Your response must be concise. -1.18e+11. What is the difference between the Trade (in US$) of Bulgaria in 2005 and the Trade (in US$) of Russian Federation in 2006?
Provide a succinct answer. -3.21e+11. What is the difference between the Trade (in US$) in Czech Republic in 2005 and the Trade (in US$) in Poland in 2006?
Ensure brevity in your answer.  -4.64e+1. What is the difference between the Trade (in US$) of Czech Republic in 2005 and the Trade (in US$) of Russian Federation in 2006?
Provide a short and direct response. -2.49e+11. What is the difference between the Trade (in US$) of Poland in 2005 and the Trade (in US$) of Russian Federation in 2006?
Keep it short and to the point. -2.28e+11. What is the average Trade (in US$) of Bulgaria per year?
Make the answer very short. 8.49e+09. What is the average Trade (in US$) in Czech Republic per year?
Provide a short and direct response. 5.36e+1. What is the average Trade (in US$) of Poland per year?
Provide a short and direct response. 7.43e+1. What is the average Trade (in US$) in Russian Federation per year?
Offer a terse response. 1.74e+11. In the year 1999, what is the difference between the Trade (in US$) in Bulgaria and Trade (in US$) in Czech Republic?
Give a very brief answer. -2.20e+1. In the year 1999, what is the difference between the Trade (in US$) of Bulgaria and Trade (in US$) of Poland?
Your answer should be very brief. -3.50e+1. In the year 1999, what is the difference between the Trade (in US$) in Bulgaria and Trade (in US$) in Russian Federation?
Give a very brief answer. -7.88e+1. In the year 1999, what is the difference between the Trade (in US$) of Czech Republic and Trade (in US$) of Poland?
Offer a terse response. -1.30e+1. In the year 1999, what is the difference between the Trade (in US$) in Czech Republic and Trade (in US$) in Russian Federation?
Keep it short and to the point. -5.68e+1. In the year 1999, what is the difference between the Trade (in US$) in Poland and Trade (in US$) in Russian Federation?
Provide a succinct answer. -4.38e+1. In the year 2000, what is the difference between the Trade (in US$) in Bulgaria and Trade (in US$) in Czech Republic?
Ensure brevity in your answer.  -2.49e+1. In the year 2000, what is the difference between the Trade (in US$) in Bulgaria and Trade (in US$) in Poland?
Give a very brief answer. -4.20e+1. In the year 2000, what is the difference between the Trade (in US$) in Bulgaria and Trade (in US$) in Russian Federation?
Provide a succinct answer. -1.10e+11. In the year 2000, what is the difference between the Trade (in US$) in Czech Republic and Trade (in US$) in Poland?
Offer a terse response. -1.71e+1. In the year 2000, what is the difference between the Trade (in US$) in Czech Republic and Trade (in US$) in Russian Federation?
Make the answer very short. -8.47e+1. In the year 2000, what is the difference between the Trade (in US$) in Poland and Trade (in US$) in Russian Federation?
Give a very brief answer. -6.77e+1. In the year 2001, what is the difference between the Trade (in US$) in Bulgaria and Trade (in US$) in Czech Republic?
Provide a succinct answer. -2.82e+1. In the year 2001, what is the difference between the Trade (in US$) of Bulgaria and Trade (in US$) of Poland?
Provide a succinct answer. -4.69e+1. In the year 2001, what is the difference between the Trade (in US$) of Bulgaria and Trade (in US$) of Russian Federation?
Your answer should be very brief. -1.08e+11. In the year 2001, what is the difference between the Trade (in US$) in Czech Republic and Trade (in US$) in Poland?
Ensure brevity in your answer.  -1.88e+1. In the year 2001, what is the difference between the Trade (in US$) of Czech Republic and Trade (in US$) of Russian Federation?
Your answer should be very brief. -8.00e+1. In the year 2001, what is the difference between the Trade (in US$) of Poland and Trade (in US$) of Russian Federation?
Your response must be concise. -6.12e+1. In the year 2002, what is the difference between the Trade (in US$) in Bulgaria and Trade (in US$) in Czech Republic?
Your answer should be very brief. -3.14e+1. In the year 2002, what is the difference between the Trade (in US$) in Bulgaria and Trade (in US$) in Poland?
Provide a short and direct response. -5.16e+1. In the year 2002, what is the difference between the Trade (in US$) in Bulgaria and Trade (in US$) in Russian Federation?
Make the answer very short. -1.16e+11. In the year 2002, what is the difference between the Trade (in US$) of Czech Republic and Trade (in US$) of Poland?
Your answer should be compact. -2.02e+1. In the year 2002, what is the difference between the Trade (in US$) of Czech Republic and Trade (in US$) of Russian Federation?
Your response must be concise. -8.47e+1. In the year 2002, what is the difference between the Trade (in US$) in Poland and Trade (in US$) in Russian Federation?
Make the answer very short. -6.45e+1. In the year 2003, what is the difference between the Trade (in US$) in Bulgaria and Trade (in US$) in Czech Republic?
Your response must be concise. -3.95e+1. In the year 2003, what is the difference between the Trade (in US$) of Bulgaria and Trade (in US$) of Poland?
Your response must be concise. -6.54e+1. In the year 2003, what is the difference between the Trade (in US$) in Bulgaria and Trade (in US$) in Russian Federation?
Offer a terse response. -1.44e+11. In the year 2003, what is the difference between the Trade (in US$) of Czech Republic and Trade (in US$) of Poland?
Provide a short and direct response. -2.59e+1. In the year 2003, what is the difference between the Trade (in US$) of Czech Republic and Trade (in US$) of Russian Federation?
Offer a terse response. -1.05e+11. In the year 2003, what is the difference between the Trade (in US$) in Poland and Trade (in US$) in Russian Federation?
Your answer should be very brief. -7.91e+1. In the year 2004, what is the difference between the Trade (in US$) of Bulgaria and Trade (in US$) of Czech Republic?
Provide a succinct answer. -5.76e+1. In the year 2004, what is the difference between the Trade (in US$) in Bulgaria and Trade (in US$) in Poland?
Provide a short and direct response. -7.71e+1. In the year 2004, what is the difference between the Trade (in US$) in Bulgaria and Trade (in US$) in Russian Federation?
Make the answer very short. -1.93e+11. In the year 2004, what is the difference between the Trade (in US$) of Czech Republic and Trade (in US$) of Poland?
Make the answer very short. -1.95e+1. In the year 2004, what is the difference between the Trade (in US$) in Czech Republic and Trade (in US$) in Russian Federation?
Ensure brevity in your answer.  -1.35e+11. In the year 2004, what is the difference between the Trade (in US$) of Poland and Trade (in US$) of Russian Federation?
Offer a terse response. -1.16e+11. In the year 2005, what is the difference between the Trade (in US$) of Bulgaria and Trade (in US$) of Czech Republic?
Your answer should be compact. -7.20e+1. In the year 2005, what is the difference between the Trade (in US$) in Bulgaria and Trade (in US$) in Poland?
Your answer should be compact. -9.36e+1. In the year 2005, what is the difference between the Trade (in US$) of Bulgaria and Trade (in US$) of Russian Federation?
Make the answer very short. -2.56e+11. In the year 2005, what is the difference between the Trade (in US$) in Czech Republic and Trade (in US$) in Poland?
Offer a terse response. -2.16e+1. In the year 2005, what is the difference between the Trade (in US$) of Czech Republic and Trade (in US$) of Russian Federation?
Your answer should be very brief. -1.84e+11. In the year 2005, what is the difference between the Trade (in US$) in Poland and Trade (in US$) in Russian Federation?
Offer a very short reply. -1.63e+11. In the year 2006, what is the difference between the Trade (in US$) in Bulgaria and Trade (in US$) in Czech Republic?
Your response must be concise. -8.52e+1. In the year 2006, what is the difference between the Trade (in US$) of Bulgaria and Trade (in US$) of Poland?
Make the answer very short. -1.15e+11. In the year 2006, what is the difference between the Trade (in US$) in Bulgaria and Trade (in US$) in Russian Federation?
Give a very brief answer. -3.18e+11. In the year 2006, what is the difference between the Trade (in US$) in Czech Republic and Trade (in US$) in Poland?
Offer a terse response. -2.98e+1. In the year 2006, what is the difference between the Trade (in US$) of Czech Republic and Trade (in US$) of Russian Federation?
Your answer should be compact. -2.33e+11. In the year 2006, what is the difference between the Trade (in US$) in Poland and Trade (in US$) in Russian Federation?
Provide a succinct answer. -2.03e+11. What is the ratio of the Trade (in US$) in Bulgaria in 1999 to that in 2000?
Offer a very short reply. 1.21. What is the ratio of the Trade (in US$) of Czech Republic in 1999 to that in 2000?
Keep it short and to the point. 0.94. What is the ratio of the Trade (in US$) of Poland in 1999 to that in 2000?
Keep it short and to the point. 0.87. What is the ratio of the Trade (in US$) in Russian Federation in 1999 to that in 2000?
Provide a short and direct response. 0.74. What is the ratio of the Trade (in US$) in Bulgaria in 1999 to that in 2001?
Offer a terse response. 1.18. What is the ratio of the Trade (in US$) in Czech Republic in 1999 to that in 2001?
Make the answer very short. 0.84. What is the ratio of the Trade (in US$) in Poland in 1999 to that in 2001?
Offer a terse response. 0.79. What is the ratio of the Trade (in US$) in Russian Federation in 1999 to that in 2001?
Keep it short and to the point. 0.75. What is the ratio of the Trade (in US$) in Bulgaria in 1999 to that in 2002?
Make the answer very short. 1.06. What is the ratio of the Trade (in US$) of Czech Republic in 1999 to that in 2002?
Offer a very short reply. 0.75. What is the ratio of the Trade (in US$) of Poland in 1999 to that in 2002?
Offer a terse response. 0.72. What is the ratio of the Trade (in US$) of Russian Federation in 1999 to that in 2002?
Offer a terse response. 0.7. What is the ratio of the Trade (in US$) in Bulgaria in 1999 to that in 2003?
Provide a succinct answer. 0.8. What is the ratio of the Trade (in US$) of Czech Republic in 1999 to that in 2003?
Provide a succinct answer. 0.6. What is the ratio of the Trade (in US$) in Poland in 1999 to that in 2003?
Your answer should be very brief. 0.56. What is the ratio of the Trade (in US$) of Russian Federation in 1999 to that in 2003?
Keep it short and to the point. 0.56. What is the ratio of the Trade (in US$) in Bulgaria in 1999 to that in 2004?
Your response must be concise. 0.54. What is the ratio of the Trade (in US$) in Czech Republic in 1999 to that in 2004?
Keep it short and to the point. 0.41. What is the ratio of the Trade (in US$) of Poland in 1999 to that in 2004?
Your answer should be very brief. 0.47. What is the ratio of the Trade (in US$) of Russian Federation in 1999 to that in 2004?
Keep it short and to the point. 0.42. What is the ratio of the Trade (in US$) in Bulgaria in 1999 to that in 2005?
Provide a succinct answer. 0.46. What is the ratio of the Trade (in US$) of Czech Republic in 1999 to that in 2005?
Offer a very short reply. 0.33. What is the ratio of the Trade (in US$) of Poland in 1999 to that in 2005?
Your response must be concise. 0.38. What is the ratio of the Trade (in US$) of Russian Federation in 1999 to that in 2005?
Offer a very short reply. 0.31. What is the ratio of the Trade (in US$) of Bulgaria in 1999 to that in 2006?
Offer a very short reply. 0.36. What is the ratio of the Trade (in US$) of Czech Republic in 1999 to that in 2006?
Give a very brief answer. 0.27. What is the ratio of the Trade (in US$) in Poland in 1999 to that in 2006?
Your answer should be compact. 0.31. What is the ratio of the Trade (in US$) in Russian Federation in 1999 to that in 2006?
Provide a succinct answer. 0.25. What is the ratio of the Trade (in US$) of Bulgaria in 2000 to that in 2001?
Keep it short and to the point. 0.97. What is the ratio of the Trade (in US$) in Czech Republic in 2000 to that in 2001?
Provide a succinct answer. 0.9. What is the ratio of the Trade (in US$) of Poland in 2000 to that in 2001?
Your response must be concise. 0.9. What is the ratio of the Trade (in US$) in Russian Federation in 2000 to that in 2001?
Your response must be concise. 1.01. What is the ratio of the Trade (in US$) in Bulgaria in 2000 to that in 2002?
Provide a succinct answer. 0.87. What is the ratio of the Trade (in US$) of Czech Republic in 2000 to that in 2002?
Offer a terse response. 0.8. What is the ratio of the Trade (in US$) in Poland in 2000 to that in 2002?
Your response must be concise. 0.82. What is the ratio of the Trade (in US$) of Russian Federation in 2000 to that in 2002?
Ensure brevity in your answer.  0.94. What is the ratio of the Trade (in US$) of Bulgaria in 2000 to that in 2003?
Your answer should be compact. 0.66. What is the ratio of the Trade (in US$) of Czech Republic in 2000 to that in 2003?
Ensure brevity in your answer.  0.64. What is the ratio of the Trade (in US$) in Poland in 2000 to that in 2003?
Make the answer very short. 0.64. What is the ratio of the Trade (in US$) of Russian Federation in 2000 to that in 2003?
Provide a succinct answer. 0.75. What is the ratio of the Trade (in US$) of Bulgaria in 2000 to that in 2004?
Keep it short and to the point. 0.45. What is the ratio of the Trade (in US$) of Czech Republic in 2000 to that in 2004?
Your response must be concise. 0.43. What is the ratio of the Trade (in US$) in Poland in 2000 to that in 2004?
Offer a very short reply. 0.53. What is the ratio of the Trade (in US$) in Russian Federation in 2000 to that in 2004?
Your answer should be compact. 0.56. What is the ratio of the Trade (in US$) in Bulgaria in 2000 to that in 2005?
Give a very brief answer. 0.38. What is the ratio of the Trade (in US$) in Czech Republic in 2000 to that in 2005?
Provide a short and direct response. 0.35. What is the ratio of the Trade (in US$) of Poland in 2000 to that in 2005?
Give a very brief answer. 0.44. What is the ratio of the Trade (in US$) in Russian Federation in 2000 to that in 2005?
Give a very brief answer. 0.43. What is the ratio of the Trade (in US$) in Bulgaria in 2000 to that in 2006?
Offer a very short reply. 0.3. What is the ratio of the Trade (in US$) in Czech Republic in 2000 to that in 2006?
Keep it short and to the point. 0.29. What is the ratio of the Trade (in US$) in Poland in 2000 to that in 2006?
Make the answer very short. 0.36. What is the ratio of the Trade (in US$) of Russian Federation in 2000 to that in 2006?
Offer a terse response. 0.34. What is the ratio of the Trade (in US$) in Bulgaria in 2001 to that in 2002?
Make the answer very short. 0.9. What is the ratio of the Trade (in US$) in Czech Republic in 2001 to that in 2002?
Make the answer very short. 0.9. What is the ratio of the Trade (in US$) in Poland in 2001 to that in 2002?
Your response must be concise. 0.91. What is the ratio of the Trade (in US$) of Russian Federation in 2001 to that in 2002?
Provide a short and direct response. 0.93. What is the ratio of the Trade (in US$) of Bulgaria in 2001 to that in 2003?
Give a very brief answer. 0.68. What is the ratio of the Trade (in US$) in Czech Republic in 2001 to that in 2003?
Keep it short and to the point. 0.71. What is the ratio of the Trade (in US$) of Poland in 2001 to that in 2003?
Ensure brevity in your answer.  0.71. What is the ratio of the Trade (in US$) in Russian Federation in 2001 to that in 2003?
Offer a terse response. 0.75. What is the ratio of the Trade (in US$) in Bulgaria in 2001 to that in 2004?
Keep it short and to the point. 0.46. What is the ratio of the Trade (in US$) of Czech Republic in 2001 to that in 2004?
Offer a very short reply. 0.48. What is the ratio of the Trade (in US$) in Poland in 2001 to that in 2004?
Your response must be concise. 0.59. What is the ratio of the Trade (in US$) in Russian Federation in 2001 to that in 2004?
Your answer should be very brief. 0.56. What is the ratio of the Trade (in US$) of Bulgaria in 2001 to that in 2005?
Offer a terse response. 0.39. What is the ratio of the Trade (in US$) of Czech Republic in 2001 to that in 2005?
Offer a terse response. 0.39. What is the ratio of the Trade (in US$) in Poland in 2001 to that in 2005?
Ensure brevity in your answer.  0.49. What is the ratio of the Trade (in US$) of Russian Federation in 2001 to that in 2005?
Offer a very short reply. 0.42. What is the ratio of the Trade (in US$) of Bulgaria in 2001 to that in 2006?
Provide a short and direct response. 0.31. What is the ratio of the Trade (in US$) in Czech Republic in 2001 to that in 2006?
Provide a short and direct response. 0.33. What is the ratio of the Trade (in US$) of Poland in 2001 to that in 2006?
Provide a short and direct response. 0.4. What is the ratio of the Trade (in US$) in Russian Federation in 2001 to that in 2006?
Offer a very short reply. 0.34. What is the ratio of the Trade (in US$) of Bulgaria in 2002 to that in 2003?
Your response must be concise. 0.76. What is the ratio of the Trade (in US$) of Czech Republic in 2002 to that in 2003?
Your response must be concise. 0.79. What is the ratio of the Trade (in US$) of Poland in 2002 to that in 2003?
Your answer should be compact. 0.79. What is the ratio of the Trade (in US$) in Russian Federation in 2002 to that in 2003?
Make the answer very short. 0.8. What is the ratio of the Trade (in US$) of Bulgaria in 2002 to that in 2004?
Provide a succinct answer. 0.52. What is the ratio of the Trade (in US$) in Czech Republic in 2002 to that in 2004?
Make the answer very short. 0.54. What is the ratio of the Trade (in US$) in Poland in 2002 to that in 2004?
Ensure brevity in your answer.  0.65. What is the ratio of the Trade (in US$) of Russian Federation in 2002 to that in 2004?
Offer a very short reply. 0.6. What is the ratio of the Trade (in US$) of Bulgaria in 2002 to that in 2005?
Offer a very short reply. 0.43. What is the ratio of the Trade (in US$) in Czech Republic in 2002 to that in 2005?
Your response must be concise. 0.44. What is the ratio of the Trade (in US$) in Poland in 2002 to that in 2005?
Keep it short and to the point. 0.54. What is the ratio of the Trade (in US$) in Russian Federation in 2002 to that in 2005?
Provide a succinct answer. 0.45. What is the ratio of the Trade (in US$) of Bulgaria in 2002 to that in 2006?
Make the answer very short. 0.34. What is the ratio of the Trade (in US$) in Czech Republic in 2002 to that in 2006?
Offer a terse response. 0.36. What is the ratio of the Trade (in US$) of Poland in 2002 to that in 2006?
Ensure brevity in your answer.  0.44. What is the ratio of the Trade (in US$) of Russian Federation in 2002 to that in 2006?
Make the answer very short. 0.36. What is the ratio of the Trade (in US$) of Bulgaria in 2003 to that in 2004?
Ensure brevity in your answer.  0.68. What is the ratio of the Trade (in US$) of Czech Republic in 2003 to that in 2004?
Offer a very short reply. 0.68. What is the ratio of the Trade (in US$) in Poland in 2003 to that in 2004?
Your answer should be compact. 0.83. What is the ratio of the Trade (in US$) in Russian Federation in 2003 to that in 2004?
Offer a very short reply. 0.75. What is the ratio of the Trade (in US$) of Bulgaria in 2003 to that in 2005?
Your answer should be compact. 0.57. What is the ratio of the Trade (in US$) of Czech Republic in 2003 to that in 2005?
Offer a very short reply. 0.55. What is the ratio of the Trade (in US$) of Poland in 2003 to that in 2005?
Provide a short and direct response. 0.68. What is the ratio of the Trade (in US$) of Russian Federation in 2003 to that in 2005?
Keep it short and to the point. 0.56. What is the ratio of the Trade (in US$) in Bulgaria in 2003 to that in 2006?
Your answer should be compact. 0.45. What is the ratio of the Trade (in US$) in Czech Republic in 2003 to that in 2006?
Give a very brief answer. 0.46. What is the ratio of the Trade (in US$) of Poland in 2003 to that in 2006?
Give a very brief answer. 0.55. What is the ratio of the Trade (in US$) in Russian Federation in 2003 to that in 2006?
Give a very brief answer. 0.45. What is the ratio of the Trade (in US$) of Bulgaria in 2004 to that in 2005?
Your answer should be very brief. 0.84. What is the ratio of the Trade (in US$) of Czech Republic in 2004 to that in 2005?
Ensure brevity in your answer.  0.81. What is the ratio of the Trade (in US$) in Poland in 2004 to that in 2005?
Offer a terse response. 0.83. What is the ratio of the Trade (in US$) of Russian Federation in 2004 to that in 2005?
Your response must be concise. 0.76. What is the ratio of the Trade (in US$) of Bulgaria in 2004 to that in 2006?
Your response must be concise. 0.66. What is the ratio of the Trade (in US$) of Czech Republic in 2004 to that in 2006?
Your answer should be very brief. 0.67. What is the ratio of the Trade (in US$) in Poland in 2004 to that in 2006?
Offer a very short reply. 0.67. What is the ratio of the Trade (in US$) of Russian Federation in 2004 to that in 2006?
Ensure brevity in your answer.  0.61. What is the ratio of the Trade (in US$) in Bulgaria in 2005 to that in 2006?
Provide a succinct answer. 0.79. What is the ratio of the Trade (in US$) of Czech Republic in 2005 to that in 2006?
Your answer should be very brief. 0.84. What is the ratio of the Trade (in US$) in Poland in 2005 to that in 2006?
Your response must be concise. 0.81. What is the ratio of the Trade (in US$) in Russian Federation in 2005 to that in 2006?
Your answer should be very brief. 0.81. What is the difference between the highest and the second highest Trade (in US$) in Bulgaria?
Ensure brevity in your answer.  3.45e+09. What is the difference between the highest and the second highest Trade (in US$) of Czech Republic?
Give a very brief answer. 1.66e+1. What is the difference between the highest and the second highest Trade (in US$) of Poland?
Keep it short and to the point. 2.48e+1. What is the difference between the highest and the second highest Trade (in US$) in Russian Federation?
Offer a very short reply. 6.50e+1. What is the difference between the highest and the lowest Trade (in US$) of Bulgaria?
Your response must be concise. 1.14e+1. What is the difference between the highest and the lowest Trade (in US$) of Czech Republic?
Provide a short and direct response. 7.35e+1. What is the difference between the highest and the lowest Trade (in US$) in Poland?
Offer a very short reply. 9.03e+1. What is the difference between the highest and the lowest Trade (in US$) of Russian Federation?
Offer a very short reply. 2.49e+11. 